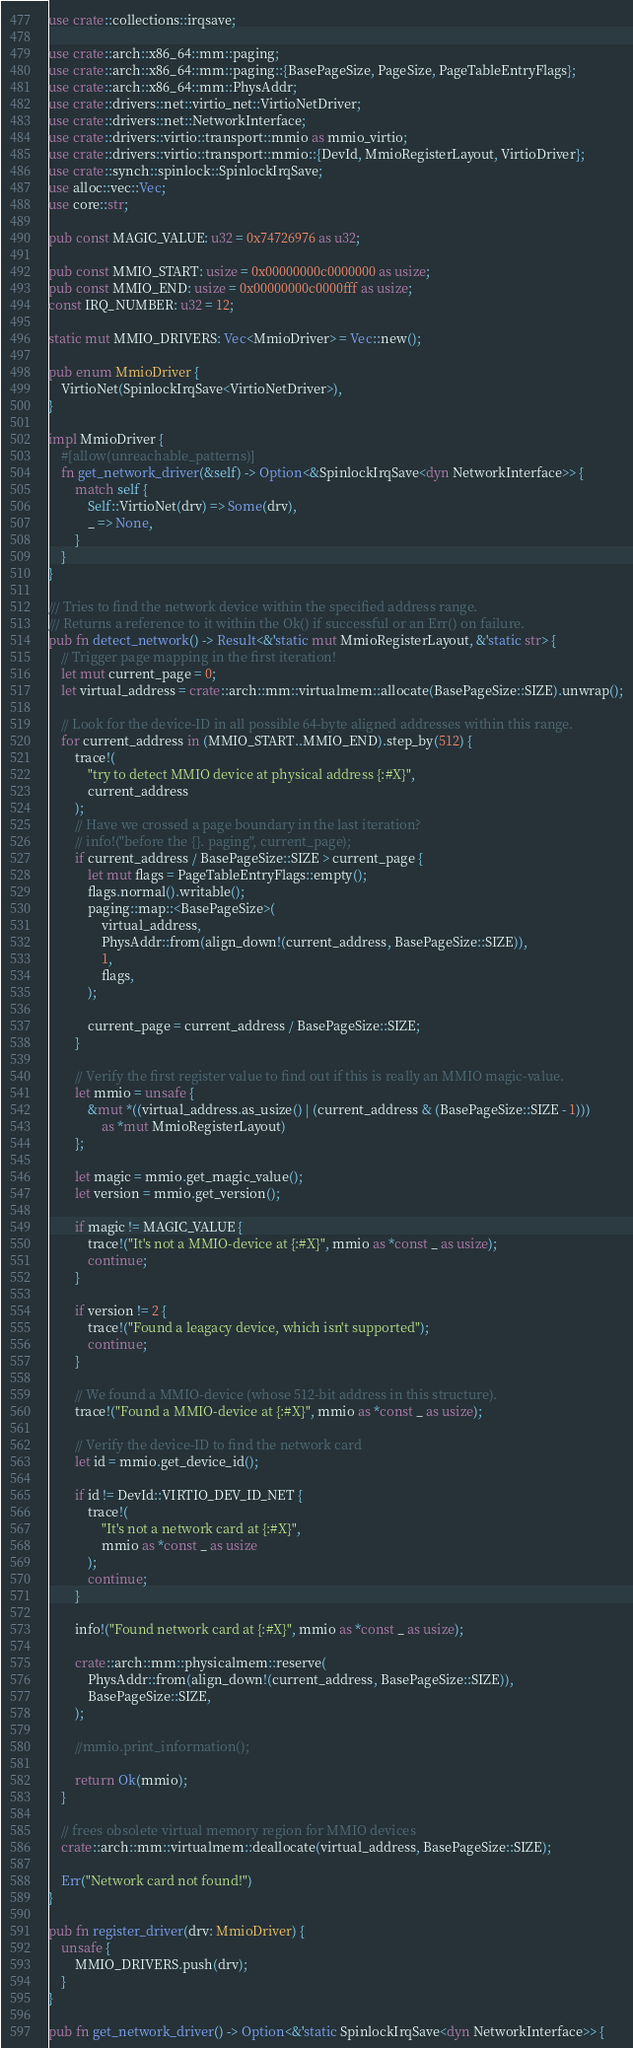<code> <loc_0><loc_0><loc_500><loc_500><_Rust_>use crate::collections::irqsave;

use crate::arch::x86_64::mm::paging;
use crate::arch::x86_64::mm::paging::{BasePageSize, PageSize, PageTableEntryFlags};
use crate::arch::x86_64::mm::PhysAddr;
use crate::drivers::net::virtio_net::VirtioNetDriver;
use crate::drivers::net::NetworkInterface;
use crate::drivers::virtio::transport::mmio as mmio_virtio;
use crate::drivers::virtio::transport::mmio::{DevId, MmioRegisterLayout, VirtioDriver};
use crate::synch::spinlock::SpinlockIrqSave;
use alloc::vec::Vec;
use core::str;

pub const MAGIC_VALUE: u32 = 0x74726976 as u32;

pub const MMIO_START: usize = 0x00000000c0000000 as usize;
pub const MMIO_END: usize = 0x00000000c0000fff as usize;
const IRQ_NUMBER: u32 = 12;

static mut MMIO_DRIVERS: Vec<MmioDriver> = Vec::new();

pub enum MmioDriver {
	VirtioNet(SpinlockIrqSave<VirtioNetDriver>),
}

impl MmioDriver {
	#[allow(unreachable_patterns)]
	fn get_network_driver(&self) -> Option<&SpinlockIrqSave<dyn NetworkInterface>> {
		match self {
			Self::VirtioNet(drv) => Some(drv),
			_ => None,
		}
	}
}

/// Tries to find the network device within the specified address range.
/// Returns a reference to it within the Ok() if successful or an Err() on failure.
pub fn detect_network() -> Result<&'static mut MmioRegisterLayout, &'static str> {
	// Trigger page mapping in the first iteration!
	let mut current_page = 0;
	let virtual_address = crate::arch::mm::virtualmem::allocate(BasePageSize::SIZE).unwrap();

	// Look for the device-ID in all possible 64-byte aligned addresses within this range.
	for current_address in (MMIO_START..MMIO_END).step_by(512) {
		trace!(
			"try to detect MMIO device at physical address {:#X}",
			current_address
		);
		// Have we crossed a page boundary in the last iteration?
		// info!("before the {}. paging", current_page);
		if current_address / BasePageSize::SIZE > current_page {
			let mut flags = PageTableEntryFlags::empty();
			flags.normal().writable();
			paging::map::<BasePageSize>(
				virtual_address,
				PhysAddr::from(align_down!(current_address, BasePageSize::SIZE)),
				1,
				flags,
			);

			current_page = current_address / BasePageSize::SIZE;
		}

		// Verify the first register value to find out if this is really an MMIO magic-value.
		let mmio = unsafe {
			&mut *((virtual_address.as_usize() | (current_address & (BasePageSize::SIZE - 1)))
				as *mut MmioRegisterLayout)
		};

		let magic = mmio.get_magic_value();
		let version = mmio.get_version();

		if magic != MAGIC_VALUE {
			trace!("It's not a MMIO-device at {:#X}", mmio as *const _ as usize);
			continue;
		}

		if version != 2 {
			trace!("Found a leagacy device, which isn't supported");
			continue;
		}

		// We found a MMIO-device (whose 512-bit address in this structure).
		trace!("Found a MMIO-device at {:#X}", mmio as *const _ as usize);

		// Verify the device-ID to find the network card
		let id = mmio.get_device_id();

		if id != DevId::VIRTIO_DEV_ID_NET {
			trace!(
				"It's not a network card at {:#X}",
				mmio as *const _ as usize
			);
			continue;
		}

		info!("Found network card at {:#X}", mmio as *const _ as usize);

		crate::arch::mm::physicalmem::reserve(
			PhysAddr::from(align_down!(current_address, BasePageSize::SIZE)),
			BasePageSize::SIZE,
		);

		//mmio.print_information();

		return Ok(mmio);
	}

	// frees obsolete virtual memory region for MMIO devices
	crate::arch::mm::virtualmem::deallocate(virtual_address, BasePageSize::SIZE);

	Err("Network card not found!")
}

pub fn register_driver(drv: MmioDriver) {
	unsafe {
		MMIO_DRIVERS.push(drv);
	}
}

pub fn get_network_driver() -> Option<&'static SpinlockIrqSave<dyn NetworkInterface>> {</code> 